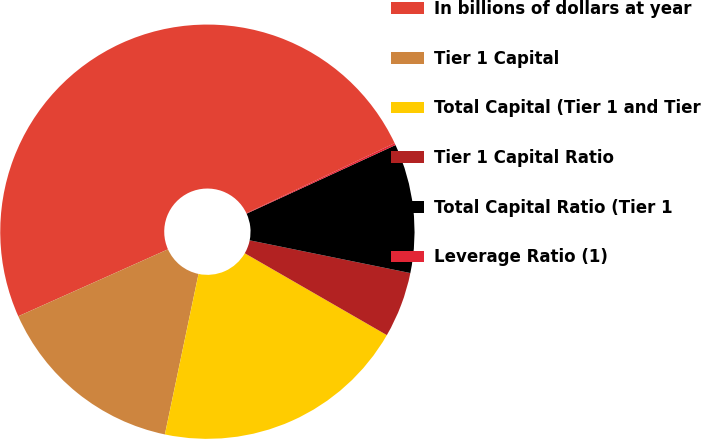Convert chart. <chart><loc_0><loc_0><loc_500><loc_500><pie_chart><fcel>In billions of dollars at year<fcel>Tier 1 Capital<fcel>Total Capital (Tier 1 and Tier<fcel>Tier 1 Capital Ratio<fcel>Total Capital Ratio (Tier 1<fcel>Leverage Ratio (1)<nl><fcel>49.67%<fcel>15.02%<fcel>19.97%<fcel>5.12%<fcel>10.07%<fcel>0.16%<nl></chart> 